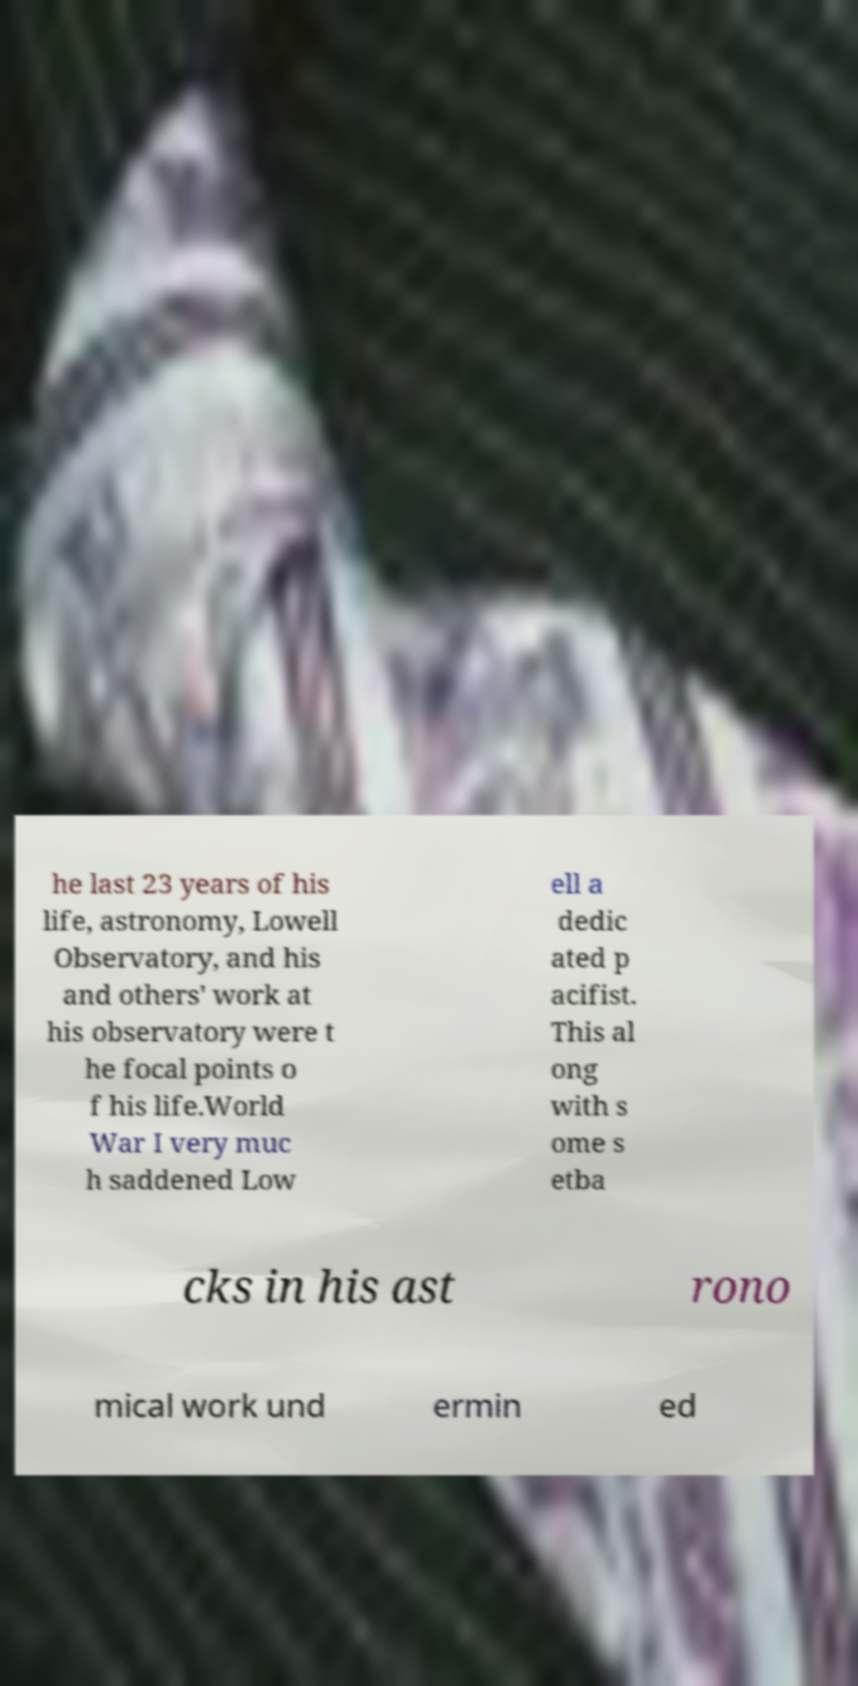Could you extract and type out the text from this image? he last 23 years of his life, astronomy, Lowell Observatory, and his and others' work at his observatory were t he focal points o f his life.World War I very muc h saddened Low ell a dedic ated p acifist. This al ong with s ome s etba cks in his ast rono mical work und ermin ed 